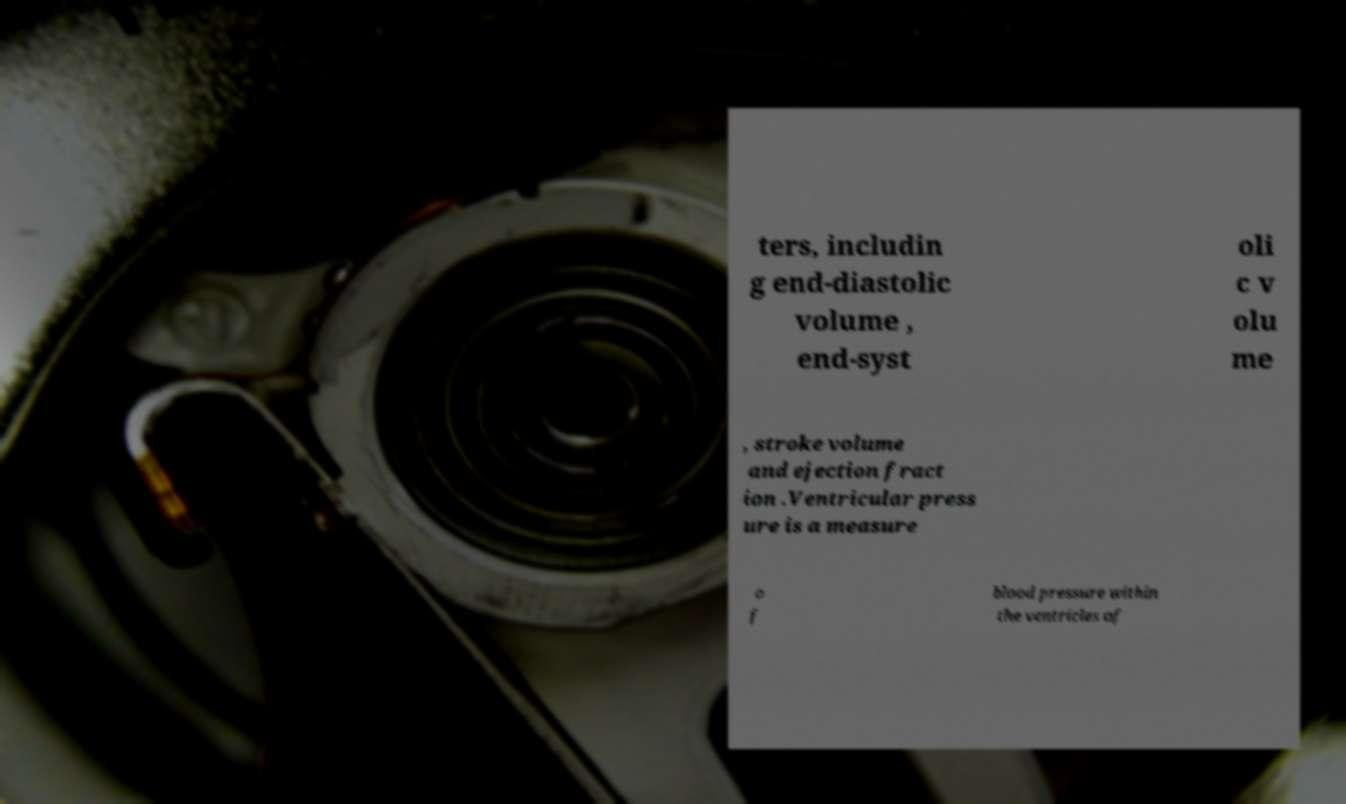Can you accurately transcribe the text from the provided image for me? ters, includin g end-diastolic volume , end-syst oli c v olu me , stroke volume and ejection fract ion .Ventricular press ure is a measure o f blood pressure within the ventricles of 